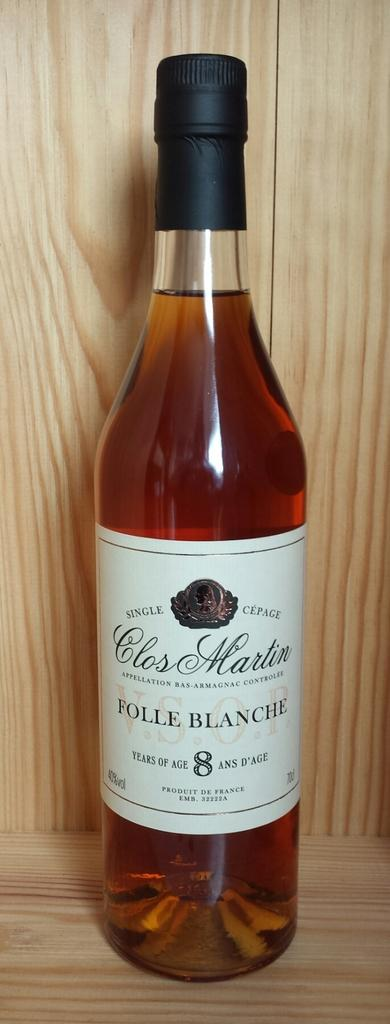<image>
Create a compact narrative representing the image presented. The cognac is aged 8 years and is a product of France. 